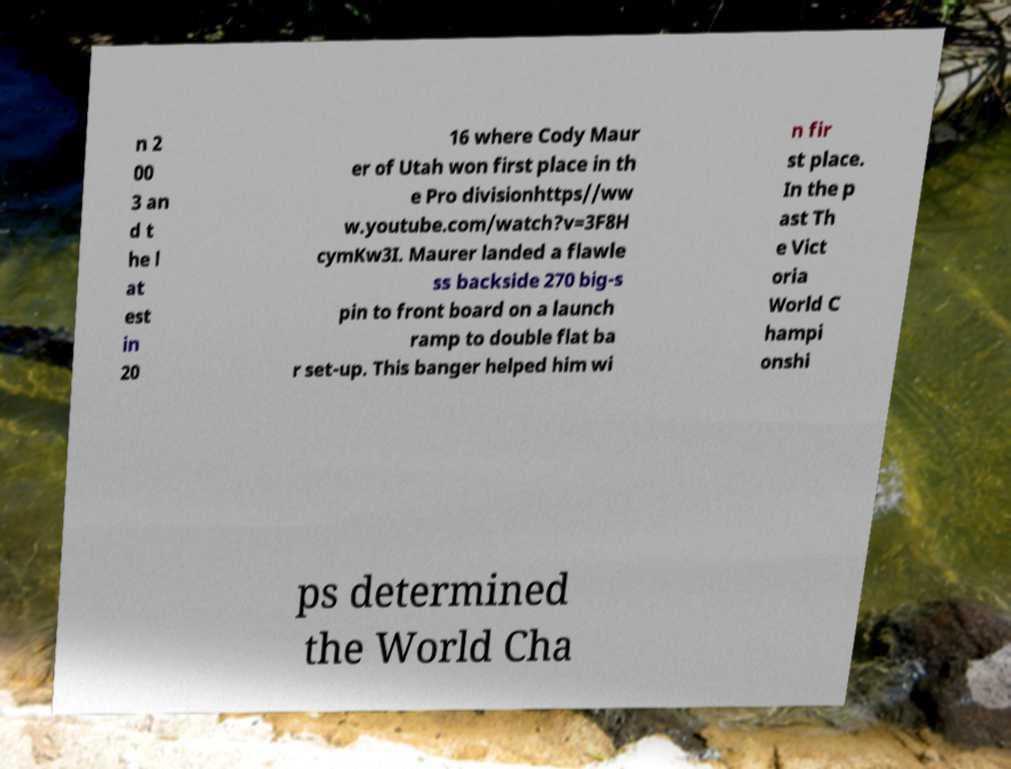What messages or text are displayed in this image? I need them in a readable, typed format. n 2 00 3 an d t he l at est in 20 16 where Cody Maur er of Utah won first place in th e Pro divisionhttps//ww w.youtube.com/watch?v=3F8H cymKw3I. Maurer landed a flawle ss backside 270 big-s pin to front board on a launch ramp to double flat ba r set-up. This banger helped him wi n fir st place. In the p ast Th e Vict oria World C hampi onshi ps determined the World Cha 